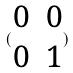Convert formula to latex. <formula><loc_0><loc_0><loc_500><loc_500>( \begin{matrix} 0 & 0 \\ 0 & 1 \end{matrix} )</formula> 